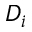Convert formula to latex. <formula><loc_0><loc_0><loc_500><loc_500>D _ { i }</formula> 